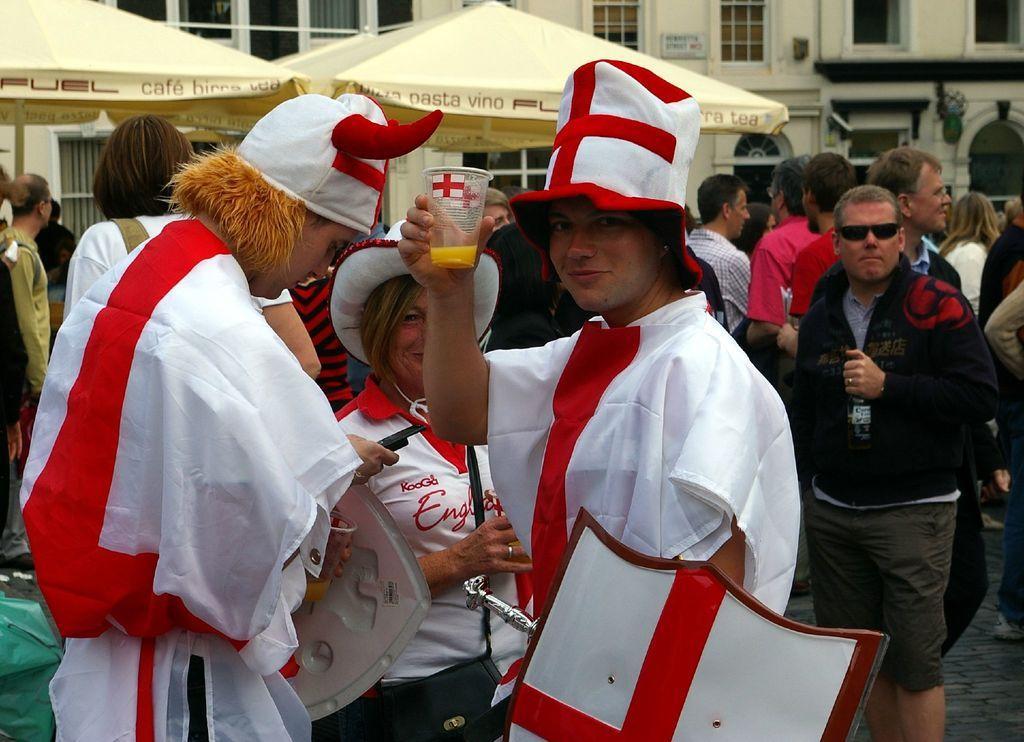Describe this image in one or two sentences. In this picture I can see three persons wearing the costumes in the middle, in the background there are people, tents and buildings. 